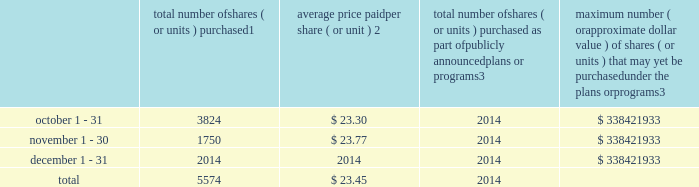Part ii item 5 .
Market for registrant 2019s common equity , related stockholder matters and issuer purchases of equity securities market information our common stock is listed and traded on the new york stock exchange under the symbol 201cipg 201d .
As of february 13 , 2019 , there were approximately 10000 registered holders of our outstanding common stock .
On february 13 , 2019 , we announced that our board of directors ( the 201cboard 201d ) had declared a common stock cash dividend of $ 0.235 per share , payable on march 15 , 2019 to holders of record as of the close of business on march 1 , 2019 .
Although it is the board 2019s current intention to declare and pay future dividends , there can be no assurance that such additional dividends will in fact be declared and paid .
Any and the amount of any such declaration is at the discretion of the board and will depend upon factors such as our earnings , financial position and cash requirements .
Equity compensation plans see item 12 for information about our equity compensation plans .
Transfer agent and registrar for common stock the transfer agent and registrar for our common stock is : computershare shareowner services llc 480 washington boulevard 29th floor jersey city , new jersey 07310 telephone : ( 877 ) 363-6398 sales of unregistered securities not applicable .
Repurchases of equity securities the table provides information regarding our purchases of our equity securities during the period from october 1 , 2018 to december 31 , 2018 .
Total number of shares ( or units ) purchased 1 average price paid per share ( or unit ) 2 total number of shares ( or units ) purchased as part of publicly announced plans or programs 3 maximum number ( or approximate dollar value ) of shares ( or units ) that may yet be purchased under the plans or programs 3 .
1 the total number of shares of our common stock , par value $ 0.10 per share , repurchased were withheld under the terms of grants under employee stock- based compensation plans to offset tax withholding obligations that occurred upon vesting and release of restricted shares ( the 201cwithheld shares 201d ) .
2 the average price per share for each of the months in the fiscal quarter and for the three-month period was calculated by dividing the sum in the applicable period of the aggregate value of the tax withholding obligations by the sum of the number of withheld shares .
3 in february 2017 , the board authorized a share repurchase program to repurchase from time to time up to $ 300.0 million , excluding fees , of our common stock ( the 201c2017 share repurchase program 201d ) .
In february 2018 , the board authorized a share repurchase program to repurchase from time to time up to $ 300.0 million , excluding fees , of our common stock , which was in addition to any amounts remaining under the 2017 share repurchase program .
On july 2 , 2018 , in connection with the announcement of the acxiom acquisition , we announced that share repurchases will be suspended for a period of time in order to reduce the increased debt levels incurred in conjunction with the acquisition , and no shares were repurchased pursuant to the share repurchase programs in the periods reflected .
There are no expiration dates associated with the share repurchase programs. .
How much more was spent on purchased shares in october than in november? 
Computations: ((3824 * 23.30) - (1750 * 23.77))
Answer: 47501.7. 